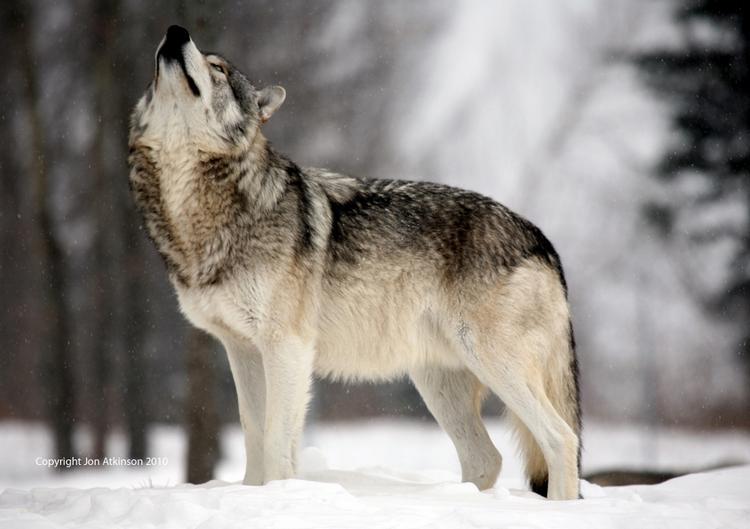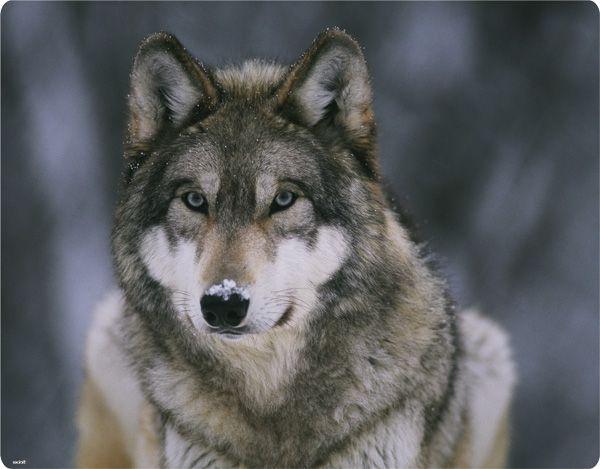The first image is the image on the left, the second image is the image on the right. Evaluate the accuracy of this statement regarding the images: "At least one wolfe has their body positioned toward the right.". Is it true? Answer yes or no. No. 